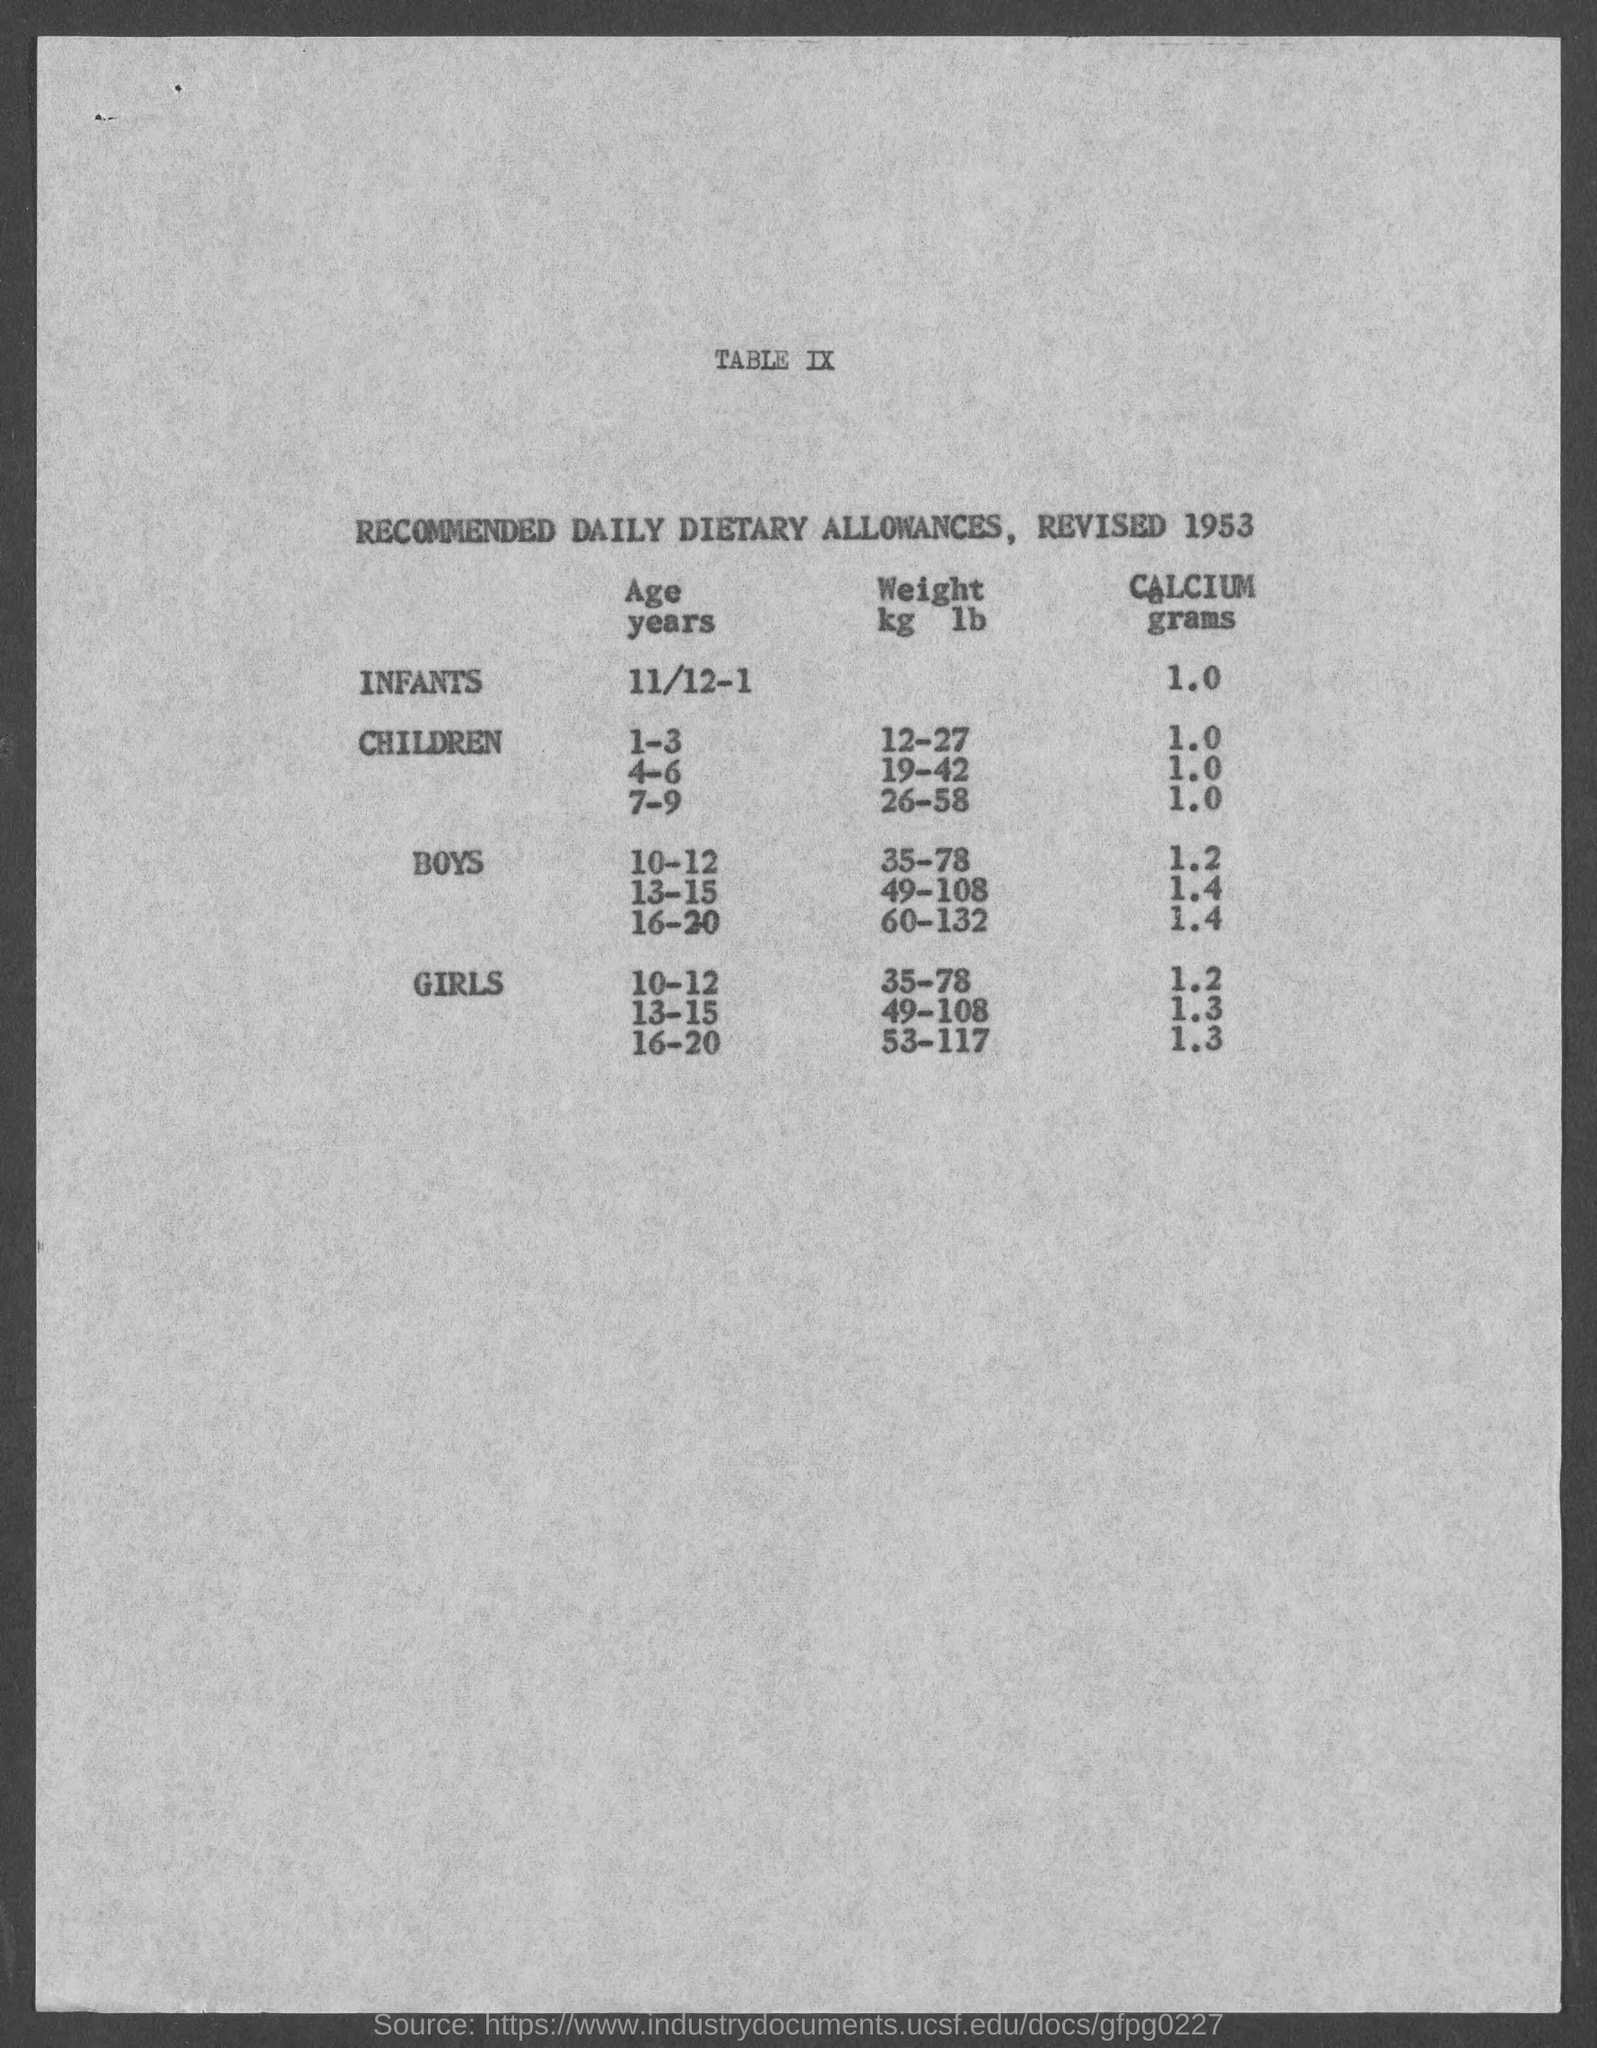What is the recommnded weight(kg/lb) for boys in the age group 10-12?
 35-78 